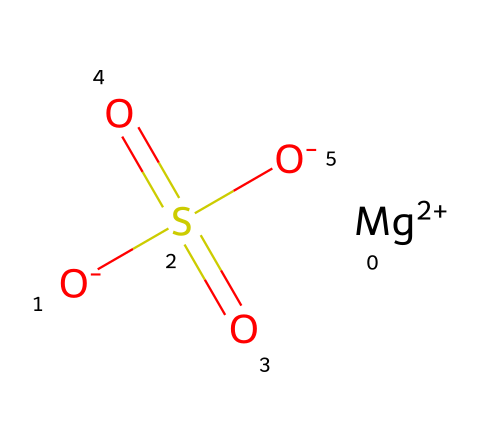What is the name of the chemical compound represented? The SMILES notation represents magnesium sulfate, which is a well-known ionic compound consisting of magnesium cations and sulfate anions.
Answer: magnesium sulfate How many oxygen atoms are in the chemical structure? By examining the SMILES representation, we can identify three oxygen atoms associated with the sulfate ion (S(=O)(=O)[O-]). Therefore, there are three oxygen atoms.
Answer: three What is the oxidation state of magnesium in this compound? The notation [Mg+2] indicates that magnesium has a +2 oxidation state, which is typical for this element when it forms ionic compounds like magnesium sulfate.
Answer: +2 What type of electrolyte is magnesium sulfate classified as? Magnesium sulfate is categorized as a strong electrolyte because it fully dissociates into its ions (Mg²⁺ and SO4²⁻) in solution, allowing for electrical conductivity.
Answer: strong electrolyte How many total atoms are present in this chemical? The chemical contains one magnesium atom, one sulfur atom, and four oxygen atoms. Therefore, the total atom count is six.
Answer: six What property allows magnesium sulfate to be used in obstetrics? Magnesium sulfate is known for its ability to manage seizures and reduce blood pressure in pregnant women, thus making it valuable in obstetrics for preventing complications.
Answer: anticonvulsant What is the geometrical shape around the sulfate ion in this compound? The sulfate ion has a tetrahedral geometry due to the four surrounding atoms (three oxygen atoms bonded to sulfur and a double bond to one oxygen), leading to a characteristic bond angle.
Answer: tetrahedral 